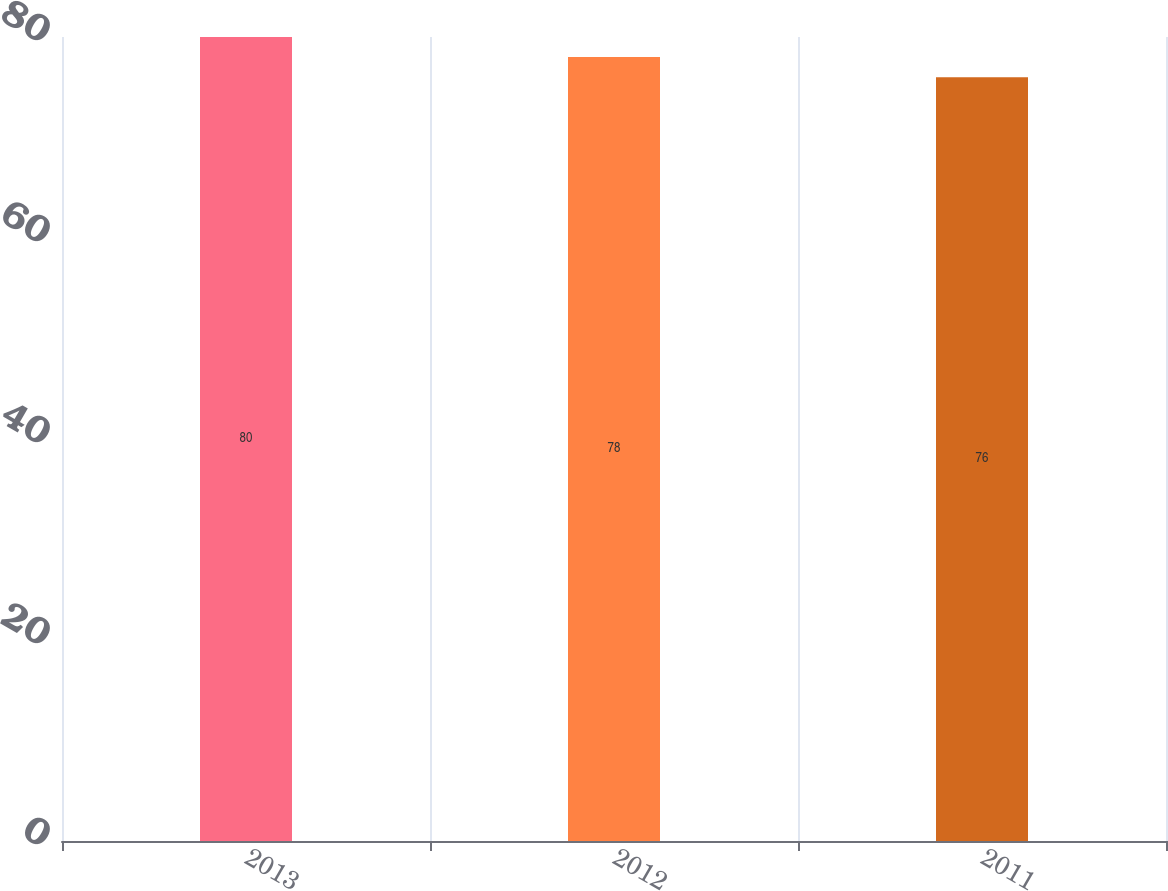Convert chart to OTSL. <chart><loc_0><loc_0><loc_500><loc_500><bar_chart><fcel>2013<fcel>2012<fcel>2011<nl><fcel>80<fcel>78<fcel>76<nl></chart> 